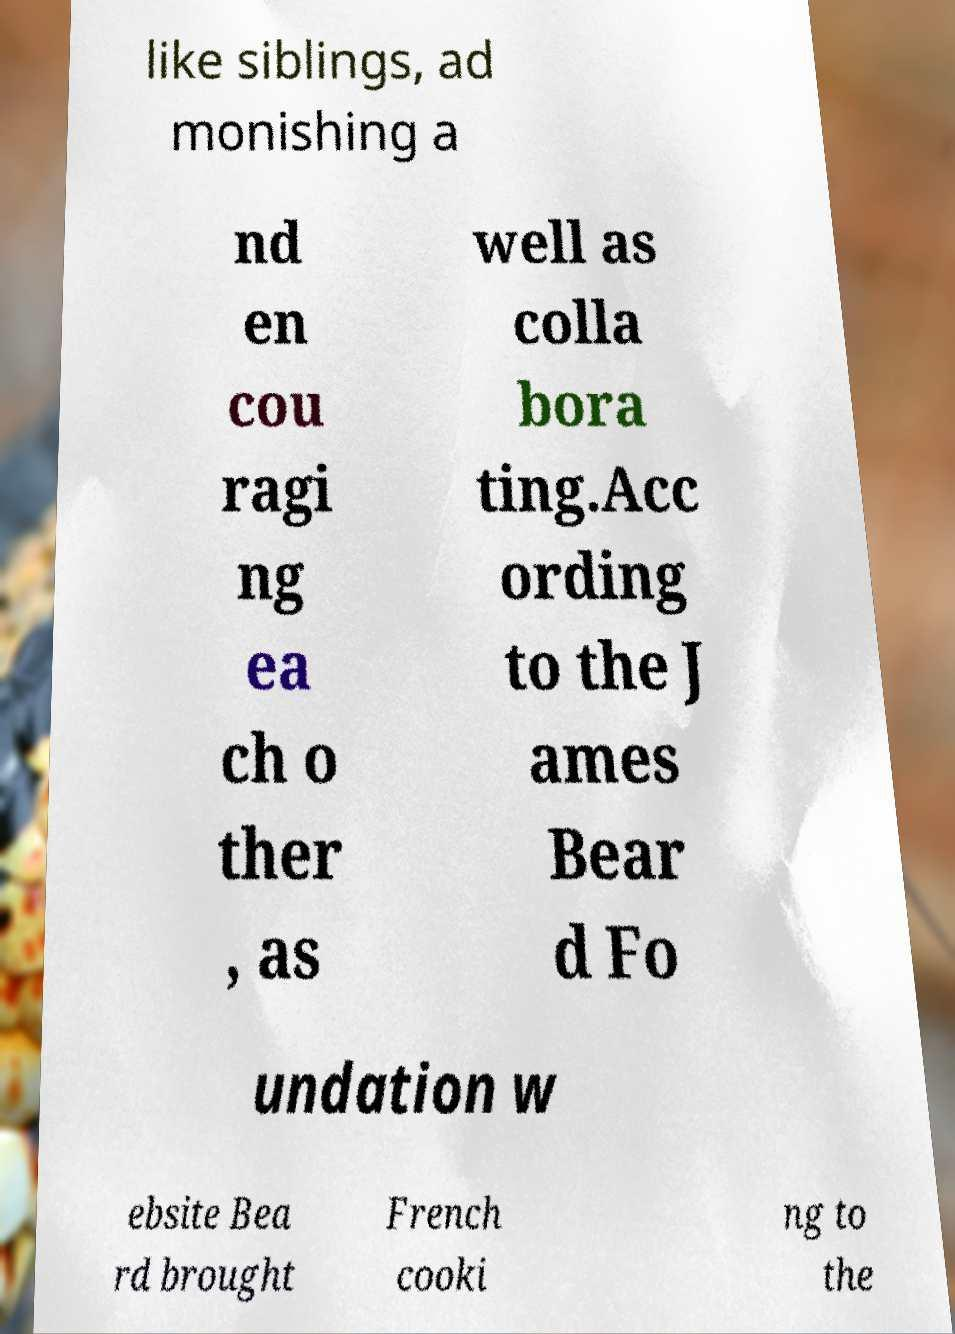Could you assist in decoding the text presented in this image and type it out clearly? like siblings, ad monishing a nd en cou ragi ng ea ch o ther , as well as colla bora ting.Acc ording to the J ames Bear d Fo undation w ebsite Bea rd brought French cooki ng to the 